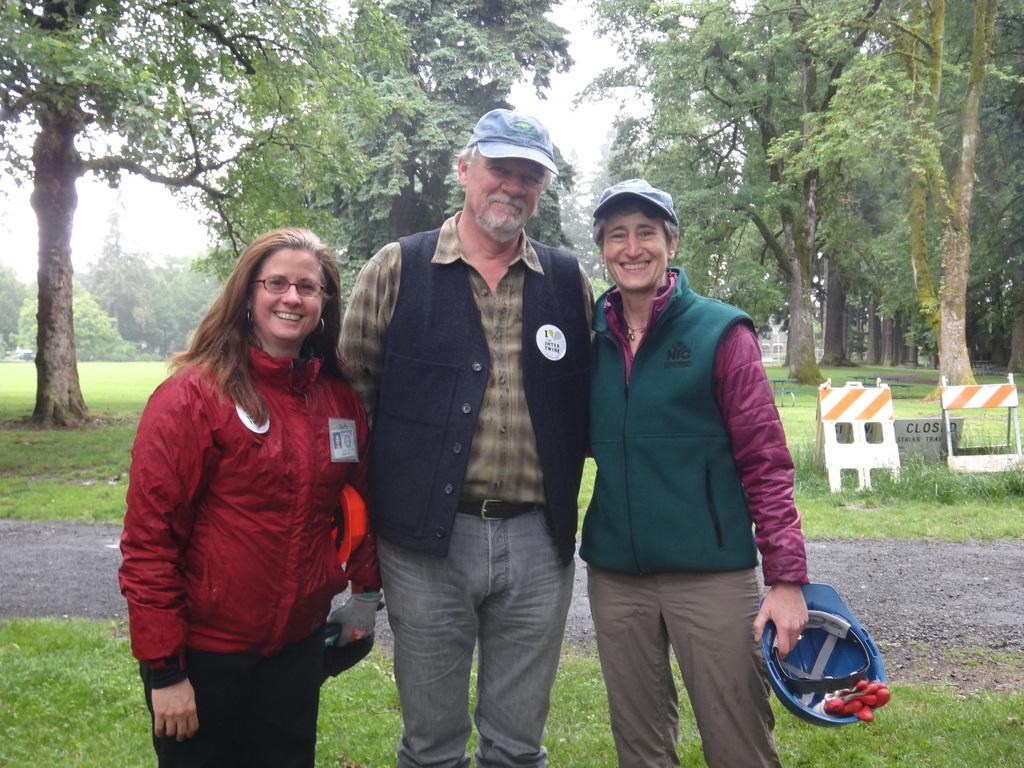How many people are in the image? There are three persons in the image. Can you describe the clothing of one of the persons? One of the persons is wearing a cap. What can be seen in the background of the image? There are trees visible in the background of the image. What type of lamp is hanging from the tree in the image? There is no lamp present in the image; it only features three persons and trees in the background. 